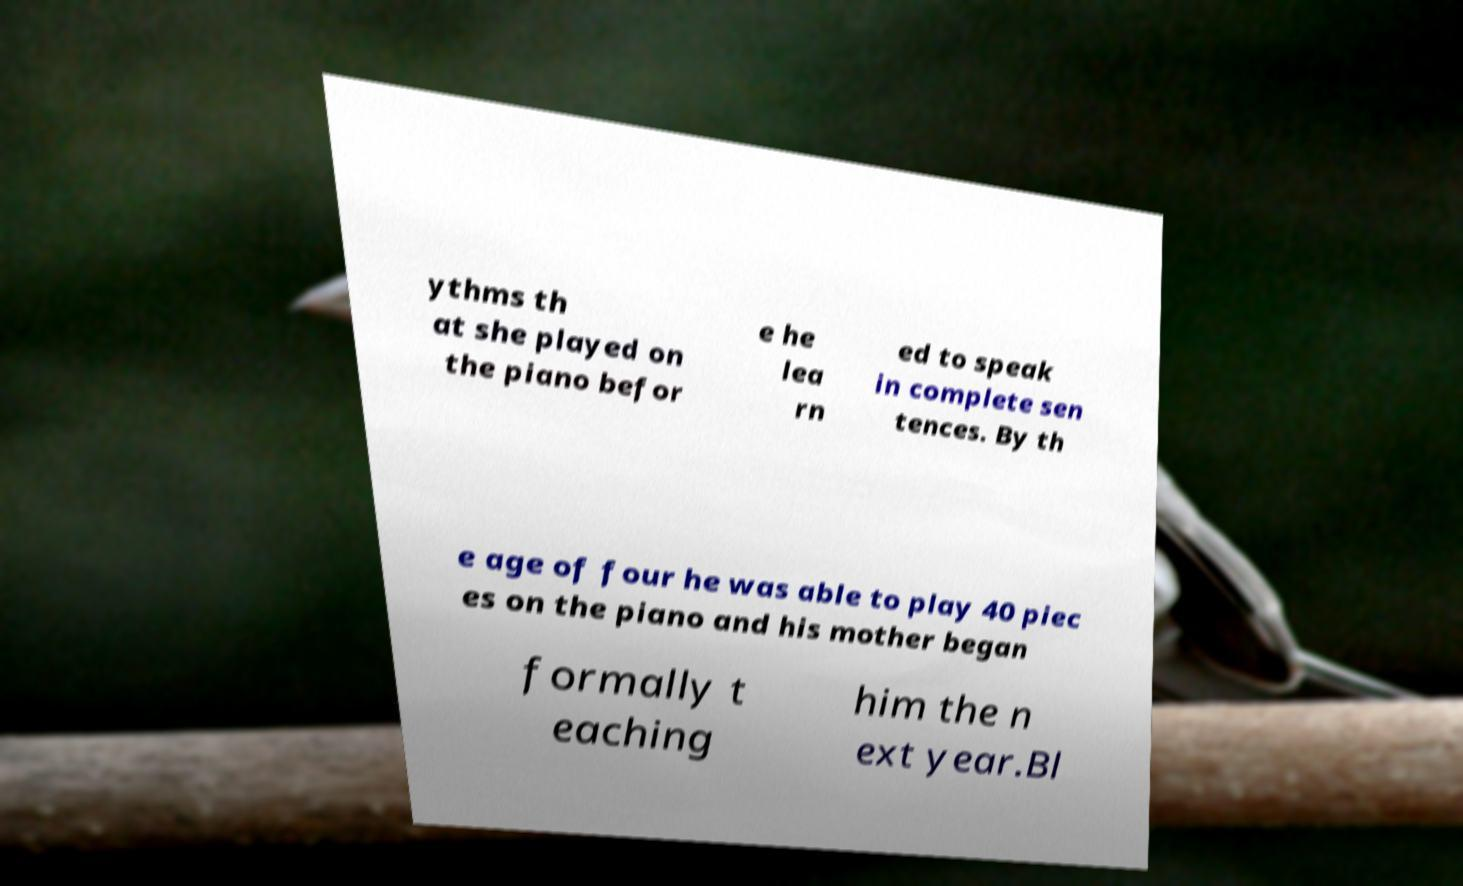Could you extract and type out the text from this image? ythms th at she played on the piano befor e he lea rn ed to speak in complete sen tences. By th e age of four he was able to play 40 piec es on the piano and his mother began formally t eaching him the n ext year.Bl 